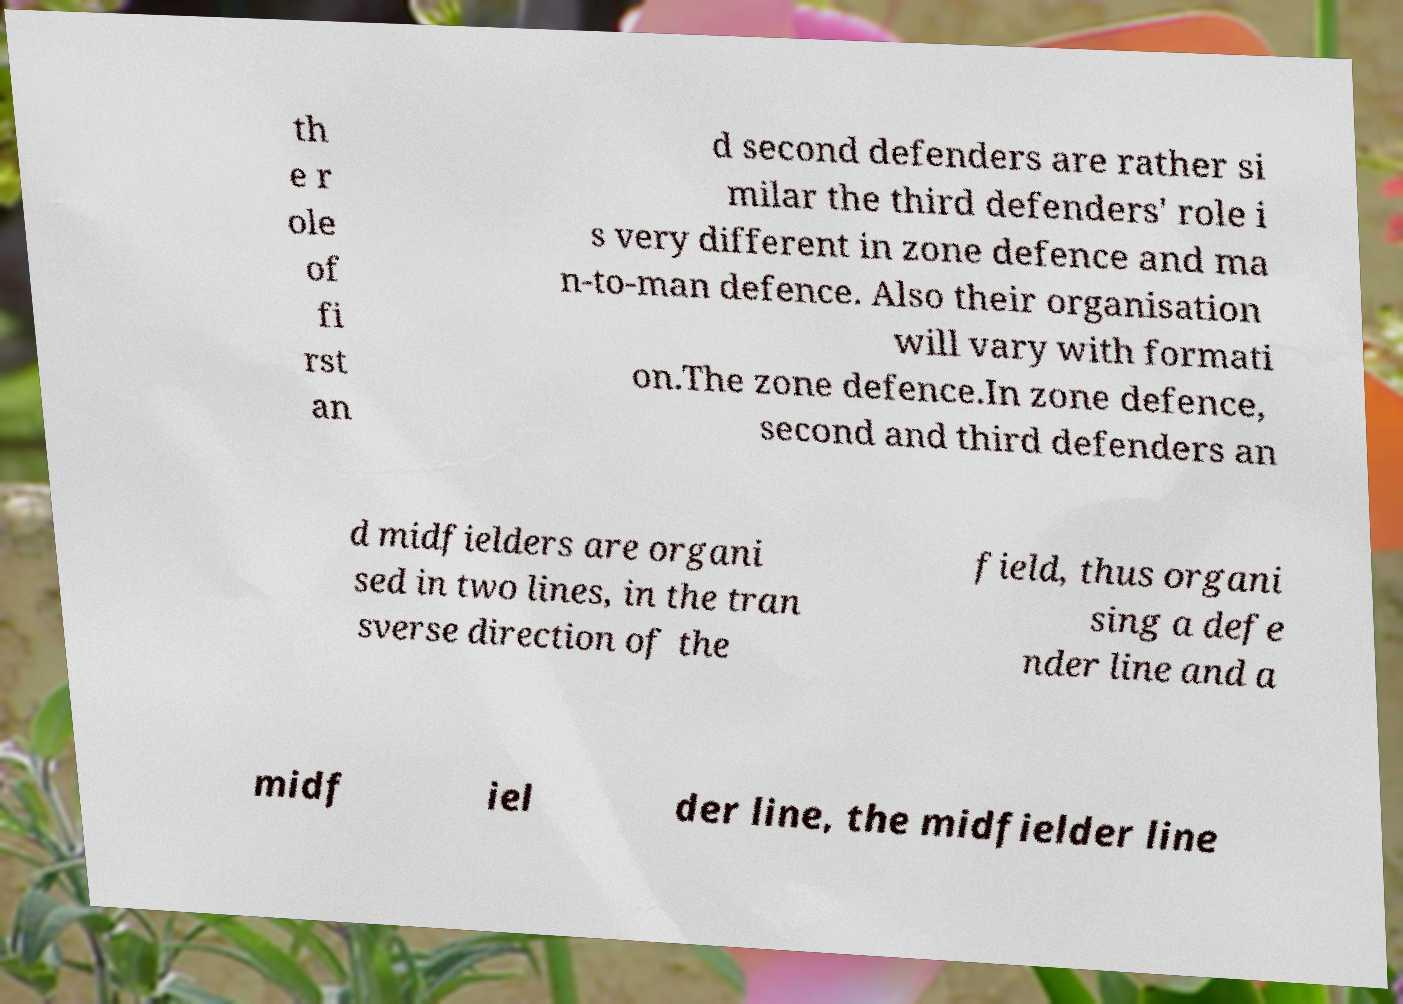I need the written content from this picture converted into text. Can you do that? th e r ole of fi rst an d second defenders are rather si milar the third defenders' role i s very different in zone defence and ma n-to-man defence. Also their organisation will vary with formati on.The zone defence.In zone defence, second and third defenders an d midfielders are organi sed in two lines, in the tran sverse direction of the field, thus organi sing a defe nder line and a midf iel der line, the midfielder line 